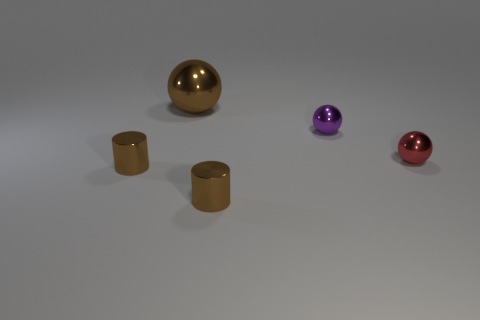What size is the red thing? The red object appears to be small, approximately the size of a table tennis ball, and is situated to the right side of the image. 